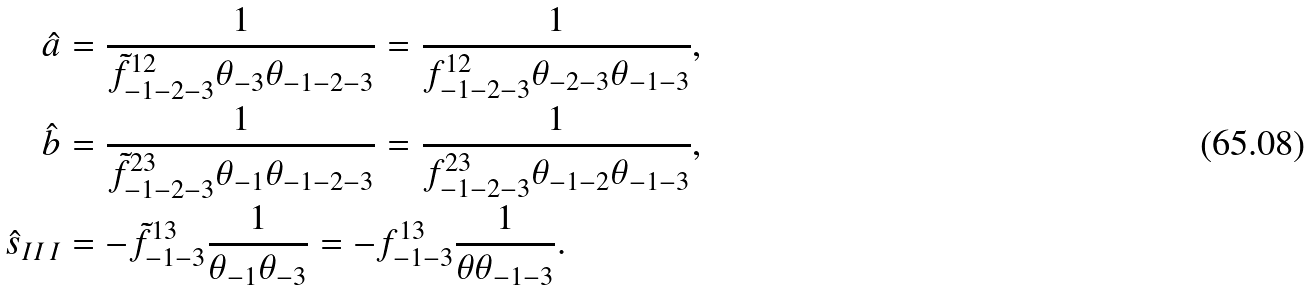<formula> <loc_0><loc_0><loc_500><loc_500>\hat { a } & = \frac { 1 } { \tilde { f } ^ { 1 2 } _ { - 1 - 2 - 3 } \theta _ { - 3 } \theta _ { - 1 - 2 - 3 } } = \frac { 1 } { f ^ { 1 2 } _ { - 1 - 2 - 3 } \theta _ { - 2 - 3 } \theta _ { - 1 - 3 } } , \\ \hat { b } & = \frac { 1 } { \tilde { f } ^ { 2 3 } _ { - 1 - 2 - 3 } \theta _ { - 1 } \theta _ { - 1 - 2 - 3 } } = \frac { 1 } { f ^ { 2 3 } _ { - 1 - 2 - 3 } \theta _ { - 1 - 2 } \theta _ { - 1 - 3 } } , \\ \hat { s } _ { I I \, I } & = - \tilde { f } ^ { 1 3 } _ { - 1 - 3 } \frac { 1 } { \theta _ { - 1 } \theta _ { - 3 } } = - f ^ { 1 3 } _ { - 1 - 3 } \frac { 1 } { \theta \theta _ { - 1 - 3 } } .</formula> 